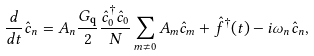Convert formula to latex. <formula><loc_0><loc_0><loc_500><loc_500>\frac { d } { d t } \hat { c } _ { n } = A _ { n } \frac { G _ { \mathbf q } } { 2 } \frac { \hat { c } _ { 0 } ^ { \dagger } \hat { c } _ { 0 } } { N } \sum _ { m \neq 0 } A _ { m } \hat { c } _ { m } + \hat { f } ^ { \dagger } ( t ) - i \omega _ { n } \hat { c } _ { n } ,</formula> 